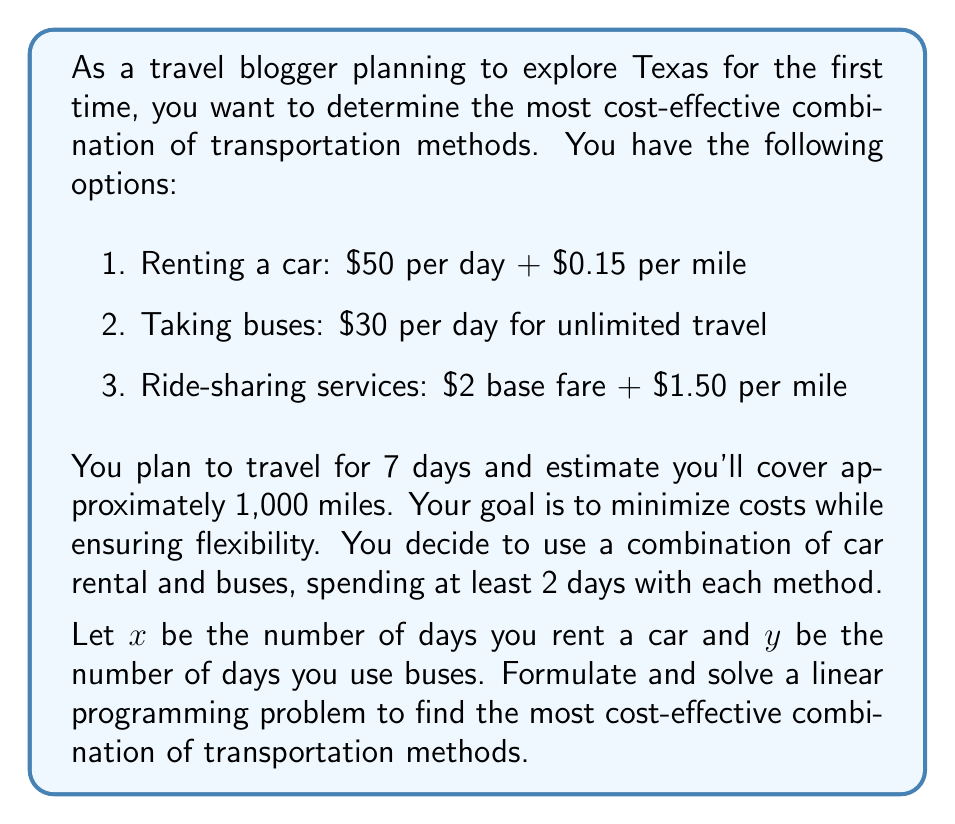Solve this math problem. To solve this linear programming problem, we need to follow these steps:

1. Define the objective function
2. Identify the constraints
3. Set up the linear programming model
4. Solve the model

Step 1: Define the objective function

The total cost will be the sum of car rental costs and bus costs:
- Car rental cost: $50x + 0.15 \cdot \frac{1000x}{7}$ (assuming equal mileage distribution)
- Bus cost: $30y$

Objective function: Minimize $Z = (50x + 0.15 \cdot \frac{1000x}{7}) + 30y$

Simplifying: Minimize $Z = 71.43x + 30y$

Step 2: Identify the constraints

- Total days: $x + y = 7$
- At least 2 days for each method: $x \geq 2$ and $y \geq 2$
- Non-negativity: $x \geq 0$ and $y \geq 0$

Step 3: Set up the linear programming model

Minimize $Z = 71.43x + 30y$
Subject to:
$x + y = 7$
$x \geq 2$
$y \geq 2$
$x, y \geq 0$

Step 4: Solve the model

We can solve this using the graphical method or simplex algorithm. Given the simplicity of the problem, we'll use the graphical method.

The feasible region is bounded by the lines:
$x + y = 7$
$x = 2$
$y = 2$

The optimal solution will be at one of the corner points of this region. The corner points are:
(2, 5), (5, 2), and (3.5, 3.5)

Evaluating the objective function at these points:
(2, 5): $Z = 71.43 \cdot 2 + 30 \cdot 5 = 292.86$
(5, 2): $Z = 71.43 \cdot 5 + 30 \cdot 2 = 417.15$
(3.5, 3.5): $Z = 71.43 \cdot 3.5 + 30 \cdot 3.5 = 355.01$

The minimum cost occurs at the point (2, 5), which means renting a car for 2 days and using buses for 5 days.
Answer: The most cost-effective combination is to rent a car for 2 days and use buses for 5 days, resulting in a total cost of $292.86. 